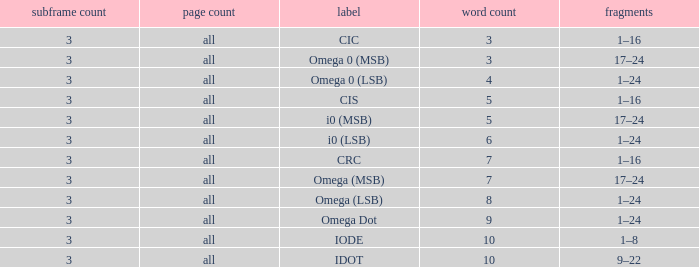What is the word count that is named omega dot? 9.0. 